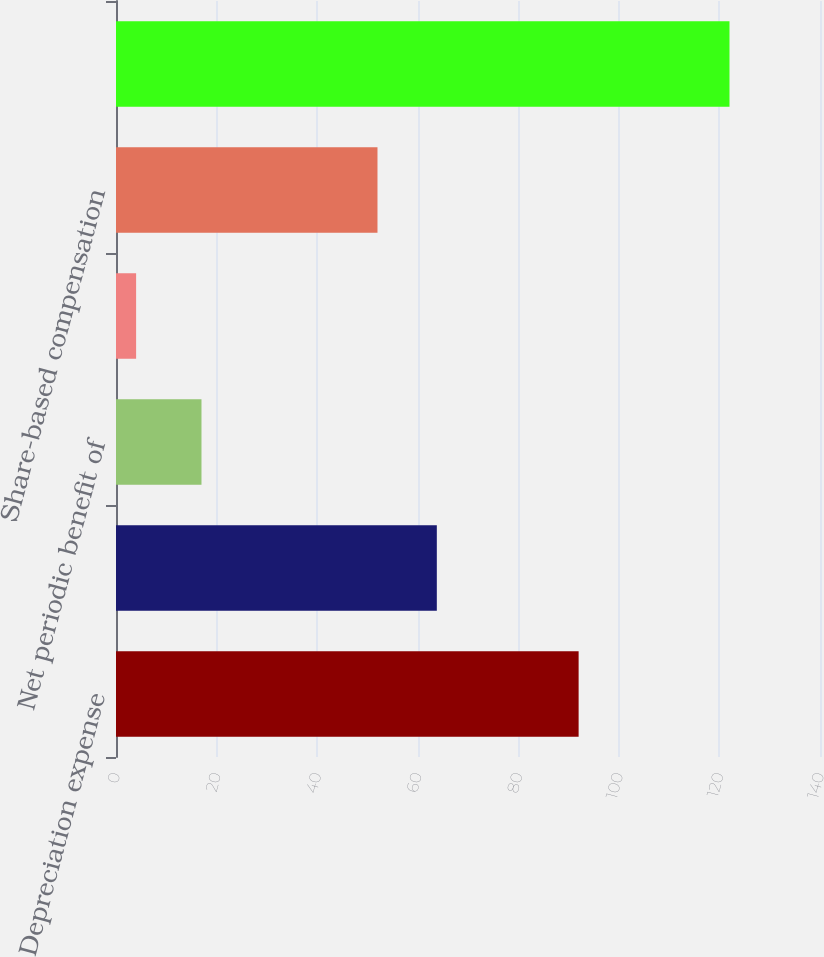Convert chart to OTSL. <chart><loc_0><loc_0><loc_500><loc_500><bar_chart><fcel>Depreciation expense<fcel>Amortization of intangible<fcel>Net periodic benefit of<fcel>Provision for doubtful<fcel>Share-based compensation<fcel>Funding of defined benefit<nl><fcel>92<fcel>63.8<fcel>17<fcel>4<fcel>52<fcel>122<nl></chart> 